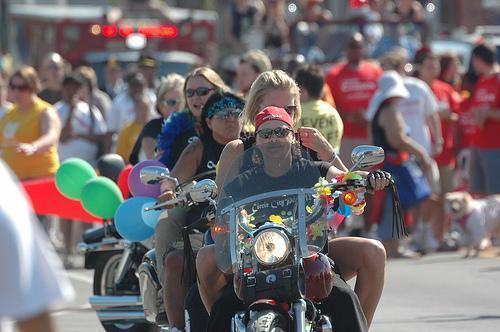How many people are on the front motorcycle?
Give a very brief answer. 2. How many blue balloons are there?
Give a very brief answer. 1. 